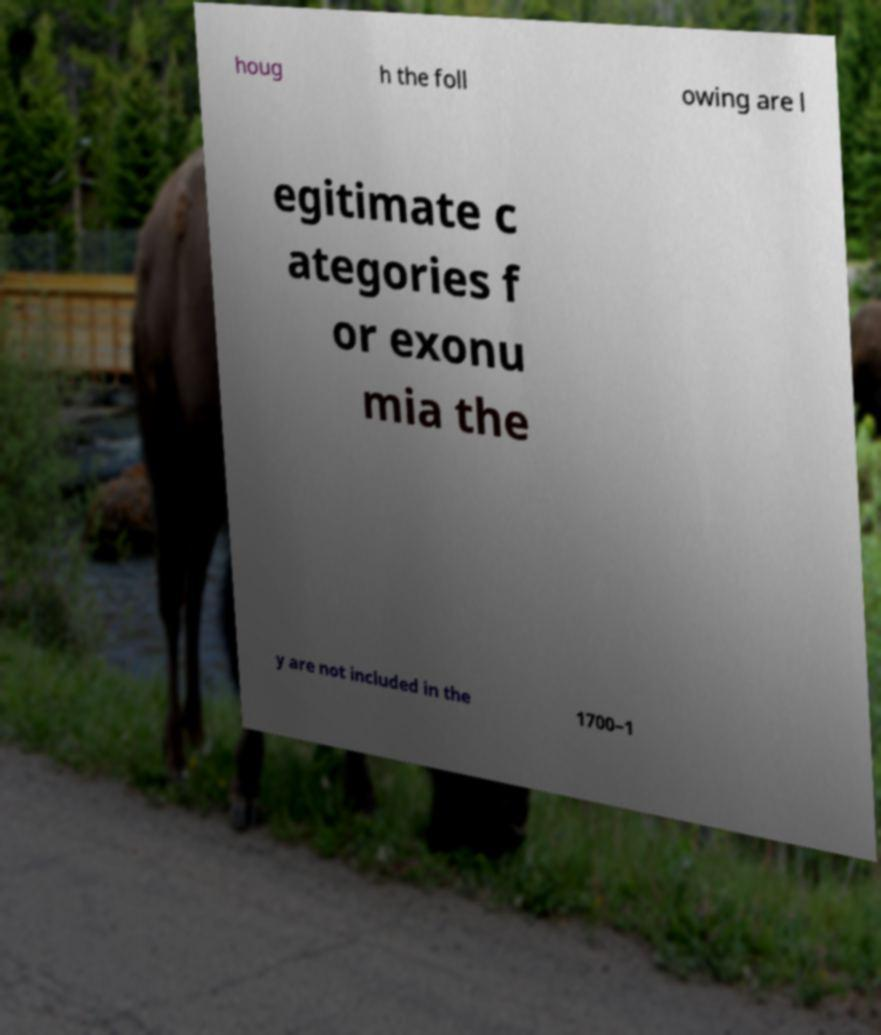Could you assist in decoding the text presented in this image and type it out clearly? houg h the foll owing are l egitimate c ategories f or exonu mia the y are not included in the 1700–1 